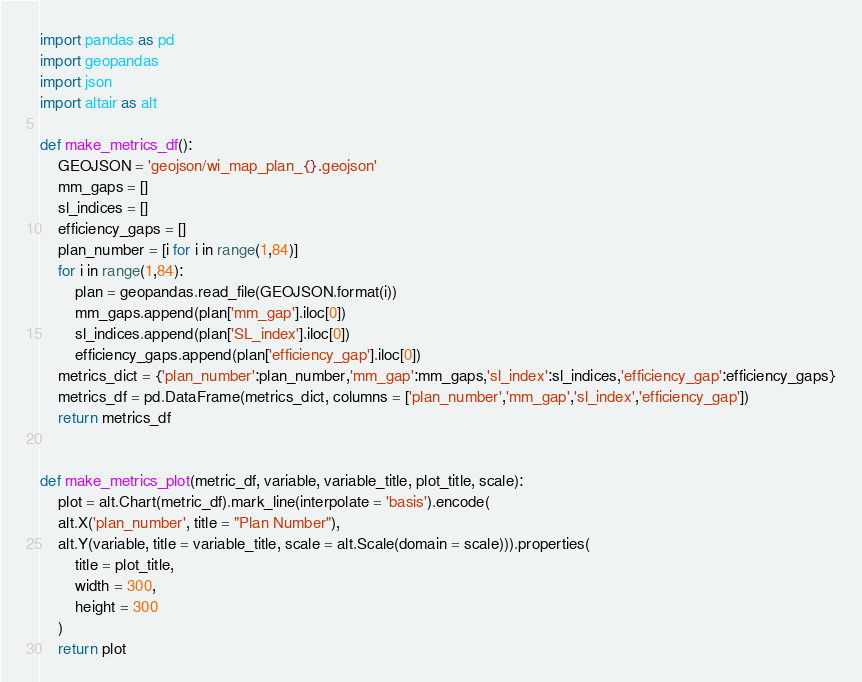<code> <loc_0><loc_0><loc_500><loc_500><_Python_>import pandas as pd
import geopandas
import json
import altair as alt

def make_metrics_df():
    GEOJSON = 'geojson/wi_map_plan_{}.geojson'
    mm_gaps = []
    sl_indices = []
    efficiency_gaps = []
    plan_number = [i for i in range(1,84)]
    for i in range(1,84):
        plan = geopandas.read_file(GEOJSON.format(i))
        mm_gaps.append(plan['mm_gap'].iloc[0])
        sl_indices.append(plan['SL_index'].iloc[0])
        efficiency_gaps.append(plan['efficiency_gap'].iloc[0])
    metrics_dict = {'plan_number':plan_number,'mm_gap':mm_gaps,'sl_index':sl_indices,'efficiency_gap':efficiency_gaps}
    metrics_df = pd.DataFrame(metrics_dict, columns = ['plan_number','mm_gap','sl_index','efficiency_gap']) 
    return metrics_df


def make_metrics_plot(metric_df, variable, variable_title, plot_title, scale):
    plot = alt.Chart(metric_df).mark_line(interpolate = 'basis').encode(
    alt.X('plan_number', title = "Plan Number"),
    alt.Y(variable, title = variable_title, scale = alt.Scale(domain = scale))).properties(
        title = plot_title,
        width = 300,
        height = 300
    )
    return plot</code> 